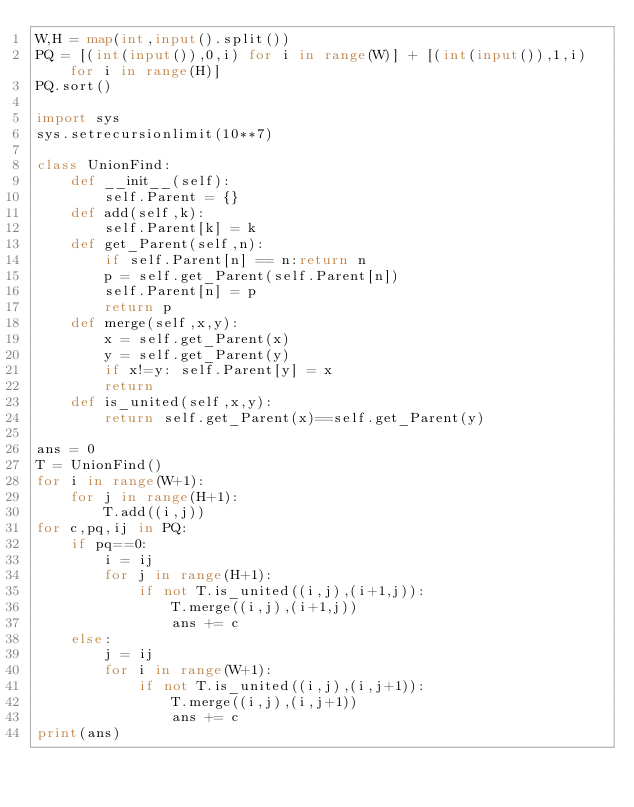Convert code to text. <code><loc_0><loc_0><loc_500><loc_500><_Python_>W,H = map(int,input().split())
PQ = [(int(input()),0,i) for i in range(W)] + [(int(input()),1,i) for i in range(H)]
PQ.sort()

import sys
sys.setrecursionlimit(10**7)

class UnionFind:
    def __init__(self):
        self.Parent = {}
    def add(self,k):
        self.Parent[k] = k
    def get_Parent(self,n):
        if self.Parent[n] == n:return n
        p = self.get_Parent(self.Parent[n])
        self.Parent[n] = p
        return p
    def merge(self,x,y):
        x = self.get_Parent(x)
        y = self.get_Parent(y)
        if x!=y: self.Parent[y] = x
        return
    def is_united(self,x,y):
        return self.get_Parent(x)==self.get_Parent(y)

ans = 0
T = UnionFind()
for i in range(W+1):
    for j in range(H+1):
        T.add((i,j))
for c,pq,ij in PQ:
    if pq==0:
        i = ij
        for j in range(H+1):
            if not T.is_united((i,j),(i+1,j)):
                T.merge((i,j),(i+1,j))
                ans += c
    else:
        j = ij
        for i in range(W+1):
            if not T.is_united((i,j),(i,j+1)):
                T.merge((i,j),(i,j+1))
                ans += c
print(ans)</code> 